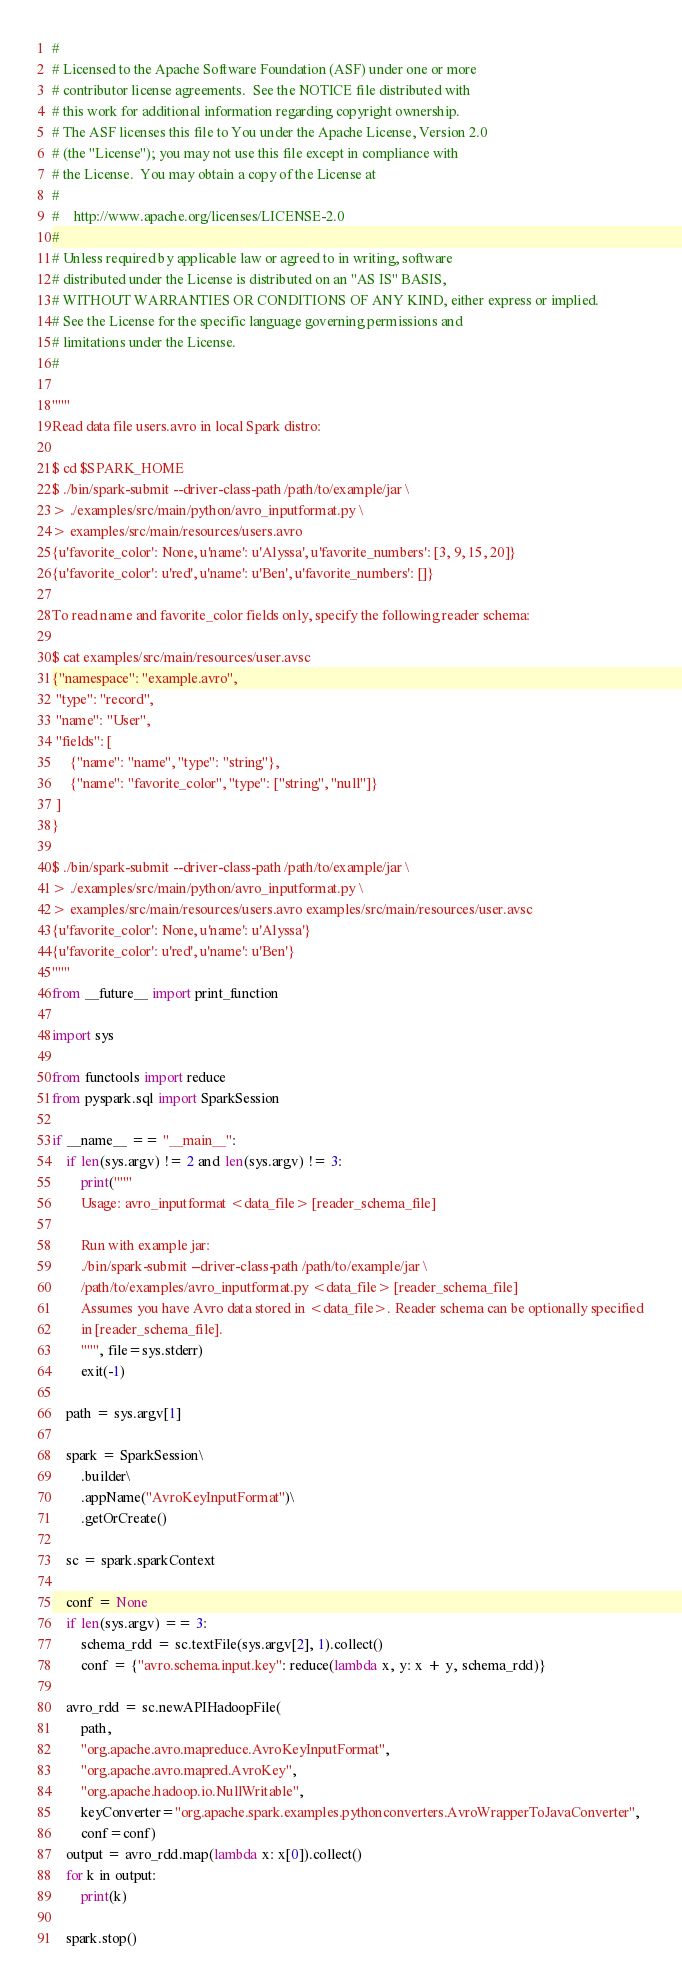<code> <loc_0><loc_0><loc_500><loc_500><_Python_>#
# Licensed to the Apache Software Foundation (ASF) under one or more
# contributor license agreements.  See the NOTICE file distributed with
# this work for additional information regarding copyright ownership.
# The ASF licenses this file to You under the Apache License, Version 2.0
# (the "License"); you may not use this file except in compliance with
# the License.  You may obtain a copy of the License at
#
#    http://www.apache.org/licenses/LICENSE-2.0
#
# Unless required by applicable law or agreed to in writing, software
# distributed under the License is distributed on an "AS IS" BASIS,
# WITHOUT WARRANTIES OR CONDITIONS OF ANY KIND, either express or implied.
# See the License for the specific language governing permissions and
# limitations under the License.
#

"""
Read data file users.avro in local Spark distro:

$ cd $SPARK_HOME
$ ./bin/spark-submit --driver-class-path /path/to/example/jar \
> ./examples/src/main/python/avro_inputformat.py \
> examples/src/main/resources/users.avro
{u'favorite_color': None, u'name': u'Alyssa', u'favorite_numbers': [3, 9, 15, 20]}
{u'favorite_color': u'red', u'name': u'Ben', u'favorite_numbers': []}

To read name and favorite_color fields only, specify the following reader schema:

$ cat examples/src/main/resources/user.avsc
{"namespace": "example.avro",
 "type": "record",
 "name": "User",
 "fields": [
     {"name": "name", "type": "string"},
     {"name": "favorite_color", "type": ["string", "null"]}
 ]
}

$ ./bin/spark-submit --driver-class-path /path/to/example/jar \
> ./examples/src/main/python/avro_inputformat.py \
> examples/src/main/resources/users.avro examples/src/main/resources/user.avsc
{u'favorite_color': None, u'name': u'Alyssa'}
{u'favorite_color': u'red', u'name': u'Ben'}
"""
from __future__ import print_function

import sys

from functools import reduce
from pyspark.sql import SparkSession

if __name__ == "__main__":
    if len(sys.argv) != 2 and len(sys.argv) != 3:
        print("""
        Usage: avro_inputformat <data_file> [reader_schema_file]

        Run with example jar:
        ./bin/spark-submit --driver-class-path /path/to/example/jar \
        /path/to/examples/avro_inputformat.py <data_file> [reader_schema_file]
        Assumes you have Avro data stored in <data_file>. Reader schema can be optionally specified
        in [reader_schema_file].
        """, file=sys.stderr)
        exit(-1)

    path = sys.argv[1]

    spark = SparkSession\
        .builder\
        .appName("AvroKeyInputFormat")\
        .getOrCreate()

    sc = spark.sparkContext

    conf = None
    if len(sys.argv) == 3:
        schema_rdd = sc.textFile(sys.argv[2], 1).collect()
        conf = {"avro.schema.input.key": reduce(lambda x, y: x + y, schema_rdd)}

    avro_rdd = sc.newAPIHadoopFile(
        path,
        "org.apache.avro.mapreduce.AvroKeyInputFormat",
        "org.apache.avro.mapred.AvroKey",
        "org.apache.hadoop.io.NullWritable",
        keyConverter="org.apache.spark.examples.pythonconverters.AvroWrapperToJavaConverter",
        conf=conf)
    output = avro_rdd.map(lambda x: x[0]).collect()
    for k in output:
        print(k)

    spark.stop()
</code> 